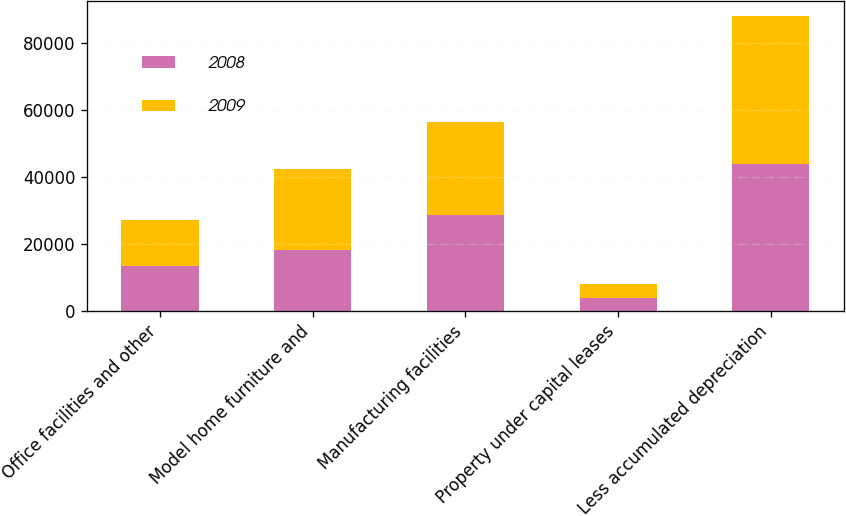Convert chart to OTSL. <chart><loc_0><loc_0><loc_500><loc_500><stacked_bar_chart><ecel><fcel>Office facilities and other<fcel>Model home furniture and<fcel>Manufacturing facilities<fcel>Property under capital leases<fcel>Less accumulated depreciation<nl><fcel>2008<fcel>13324<fcel>18354<fcel>28581<fcel>3976<fcel>44020<nl><fcel>2009<fcel>13908<fcel>24003<fcel>27957<fcel>3976<fcel>44186<nl></chart> 